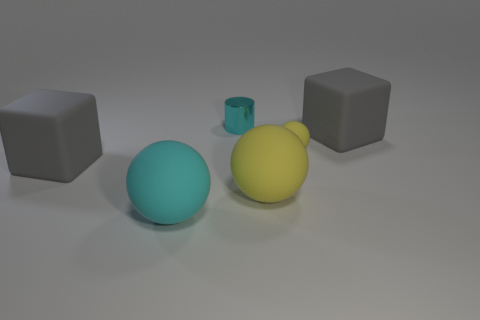What number of tiny objects are either cylinders or cyan objects?
Your response must be concise. 1. Are there any large cyan objects of the same shape as the tiny yellow matte object?
Ensure brevity in your answer.  Yes. Is the large yellow rubber thing the same shape as the small rubber thing?
Your response must be concise. Yes. The block left of the cube to the right of the tiny cyan thing is what color?
Offer a terse response. Gray. What is the color of the sphere that is the same size as the metal object?
Offer a very short reply. Yellow. What number of matte things are either yellow things or cyan spheres?
Your answer should be very brief. 3. There is a big gray matte thing that is on the left side of the small yellow object; how many cyan metallic cylinders are on the left side of it?
Your answer should be very brief. 0. There is another thing that is the same color as the metal thing; what size is it?
Ensure brevity in your answer.  Large. How many objects are either small purple metallic things or big things in front of the tiny cyan thing?
Keep it short and to the point. 4. Is there a cube that has the same material as the cylinder?
Keep it short and to the point. No. 